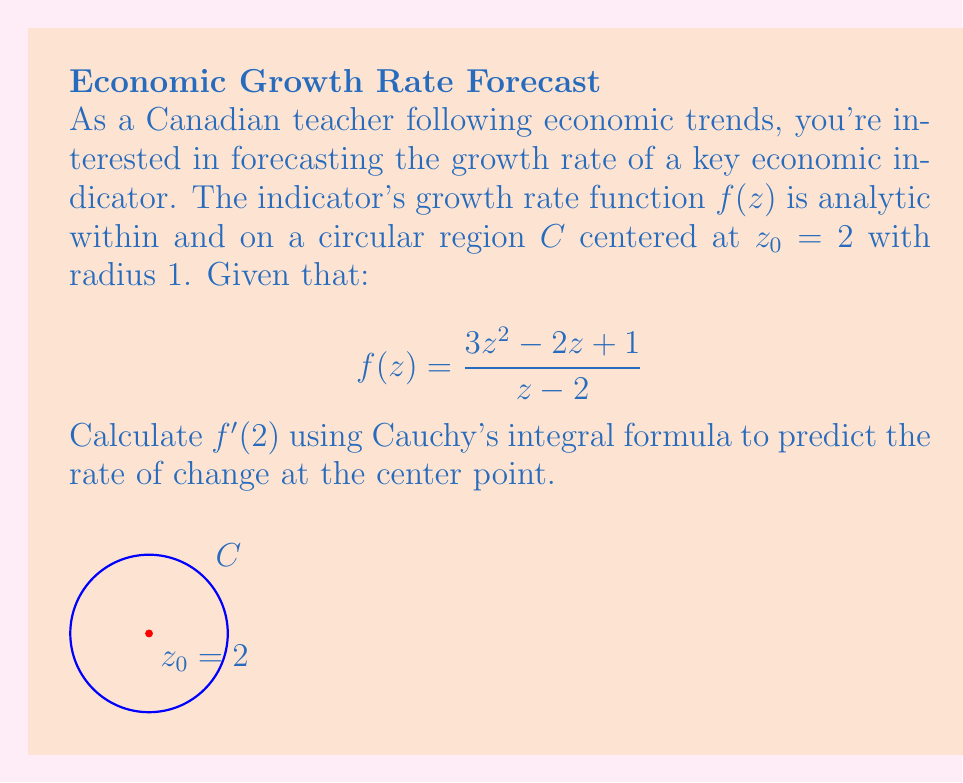Show me your answer to this math problem. Let's approach this step-by-step using Cauchy's integral formula:

1) Cauchy's integral formula for derivatives states:

   $$f^{(n)}(z_0) = \frac{n!}{2\pi i} \oint_C \frac{f(z)}{(z-z_0)^{n+1}} dz$$

2) For $f'(z_0)$, we use $n = 1$:

   $$f'(z_0) = \frac{1!}{2\pi i} \oint_C \frac{f(z)}{(z-z_0)^2} dz$$

3) Substituting $z_0 = 2$ and our given $f(z)$:

   $$f'(2) = \frac{1}{2\pi i} \oint_C \frac{(3z^2 - 2z + 1)/(z-2)}{(z-2)^2} dz$$

4) Simplify the integrand:

   $$f'(2) = \frac{1}{2\pi i} \oint_C \frac{3z^2 - 2z + 1}{(z-2)^3} dz$$

5) Now, we can use the power series expansion of the integrand around $z = 2$:

   $$\frac{3z^2 - 2z + 1}{(z-2)^3} = 3 + 5(z-2) + 4(z-2)^2 + \cdots$$

6) The Cauchy integral formula picks out the coefficient of $(z-2)^{-1}$, which is 5 in this case.

7) Therefore:

   $$f'(2) = 5$$

This result indicates that the rate of change of the economic indicator at the center point $z_0 = 2$ is 5.
Answer: $f'(2) = 5$ 